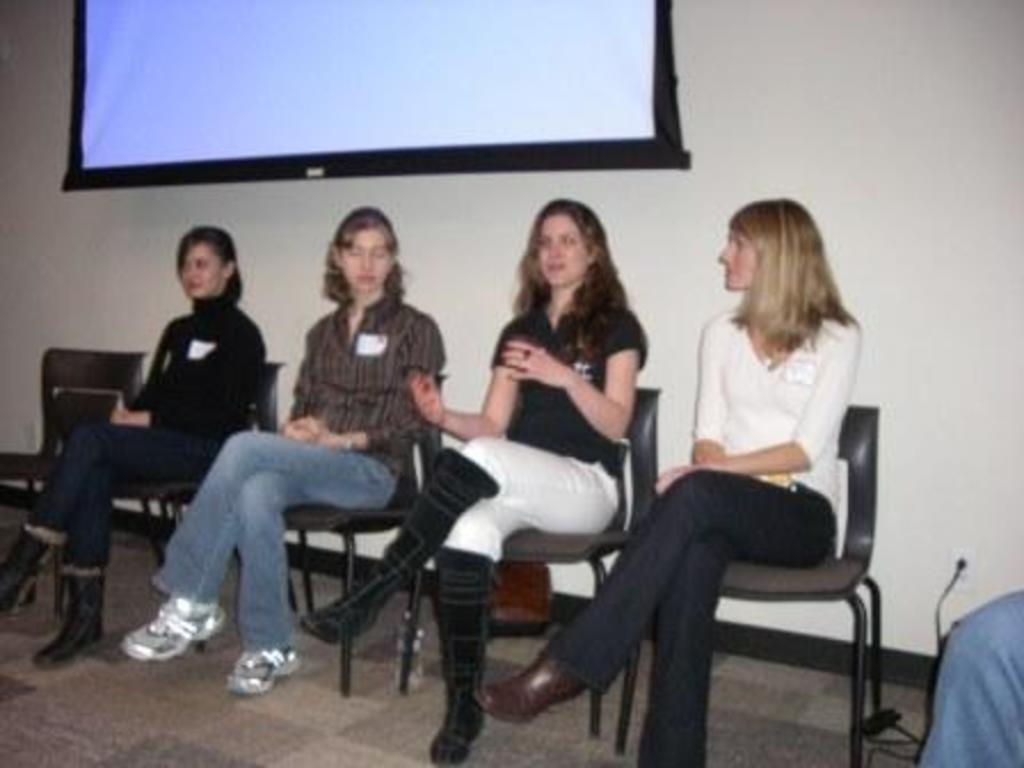How many women are present in the image? There are four women in the image. What are the women doing in the image? The women are sitting on chairs. What can be seen in the background of the image? There is a white projector screen in the background. What is covering the floor in the image? The floor is covered with a carpet. What type of silk material is draped over the chairs in the image? There is no silk material draped over the chairs in the image; the women are simply sitting on them. 